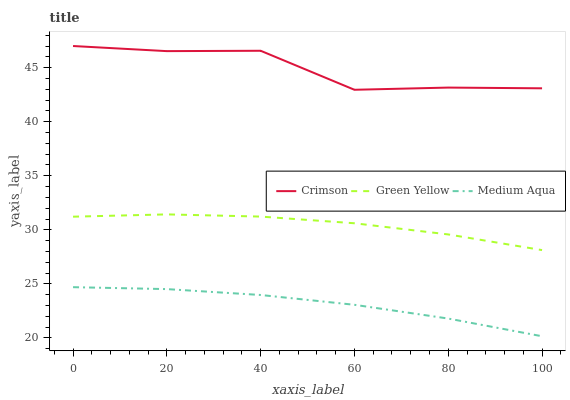Does Green Yellow have the minimum area under the curve?
Answer yes or no. No. Does Green Yellow have the maximum area under the curve?
Answer yes or no. No. Is Green Yellow the smoothest?
Answer yes or no. No. Is Green Yellow the roughest?
Answer yes or no. No. Does Green Yellow have the lowest value?
Answer yes or no. No. Does Green Yellow have the highest value?
Answer yes or no. No. Is Medium Aqua less than Crimson?
Answer yes or no. Yes. Is Green Yellow greater than Medium Aqua?
Answer yes or no. Yes. Does Medium Aqua intersect Crimson?
Answer yes or no. No. 